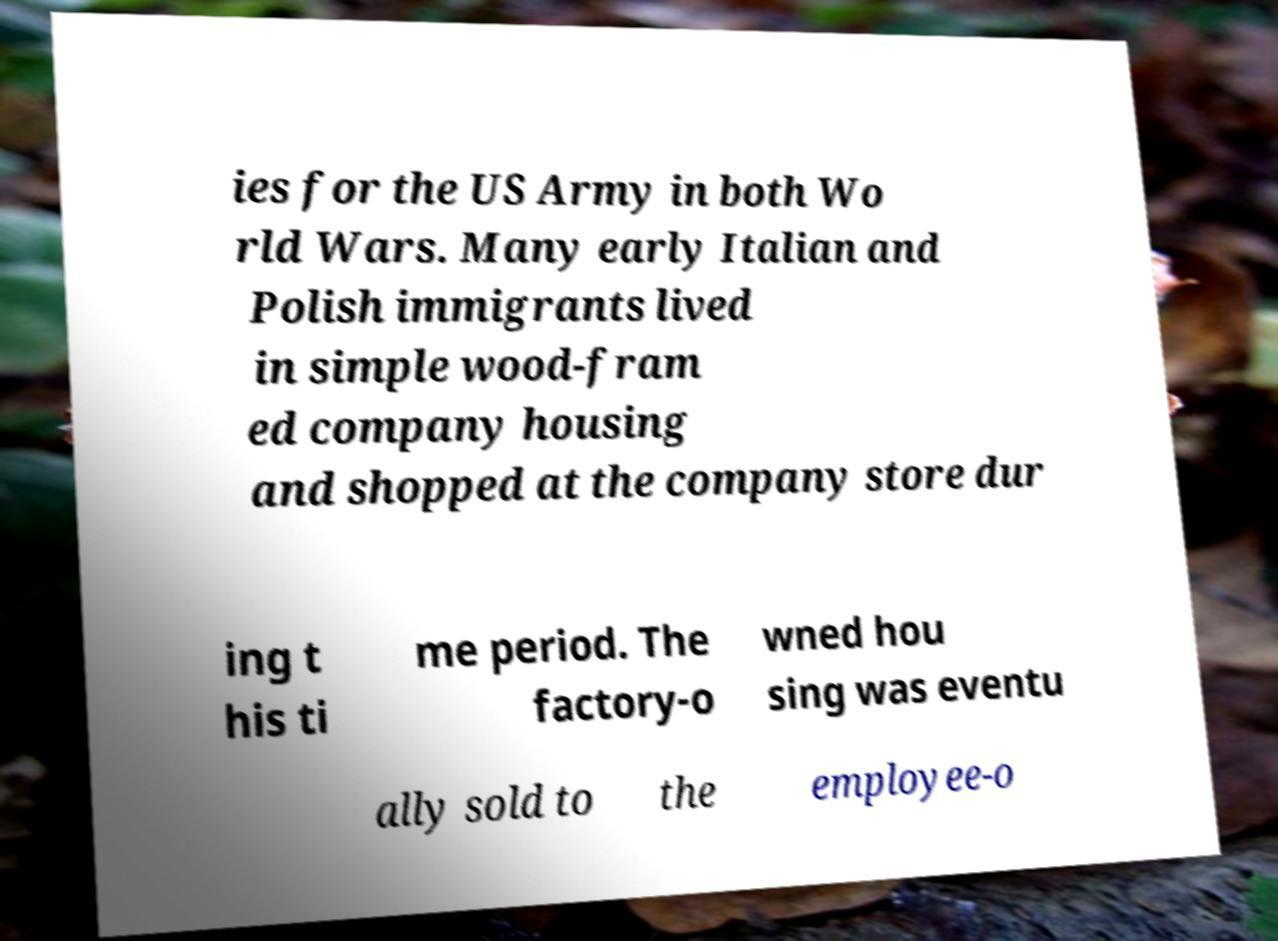For documentation purposes, I need the text within this image transcribed. Could you provide that? ies for the US Army in both Wo rld Wars. Many early Italian and Polish immigrants lived in simple wood-fram ed company housing and shopped at the company store dur ing t his ti me period. The factory-o wned hou sing was eventu ally sold to the employee-o 